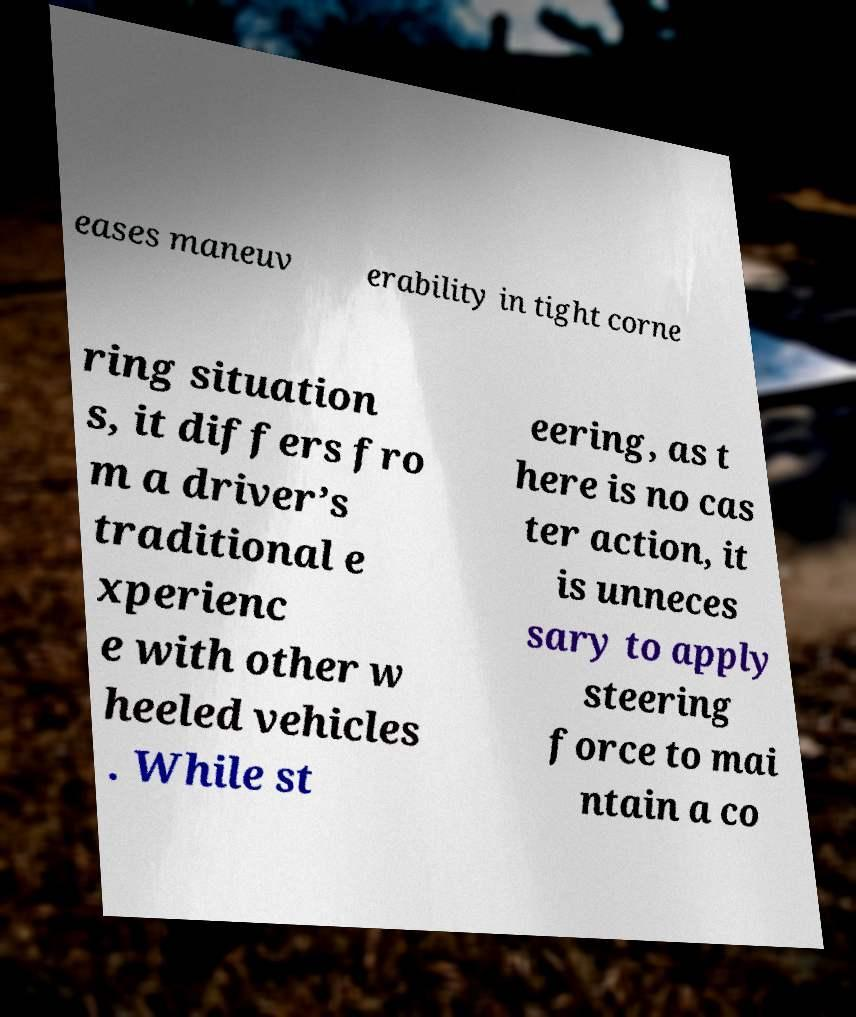Can you read and provide the text displayed in the image?This photo seems to have some interesting text. Can you extract and type it out for me? eases maneuv erability in tight corne ring situation s, it differs fro m a driver’s traditional e xperienc e with other w heeled vehicles . While st eering, as t here is no cas ter action, it is unneces sary to apply steering force to mai ntain a co 